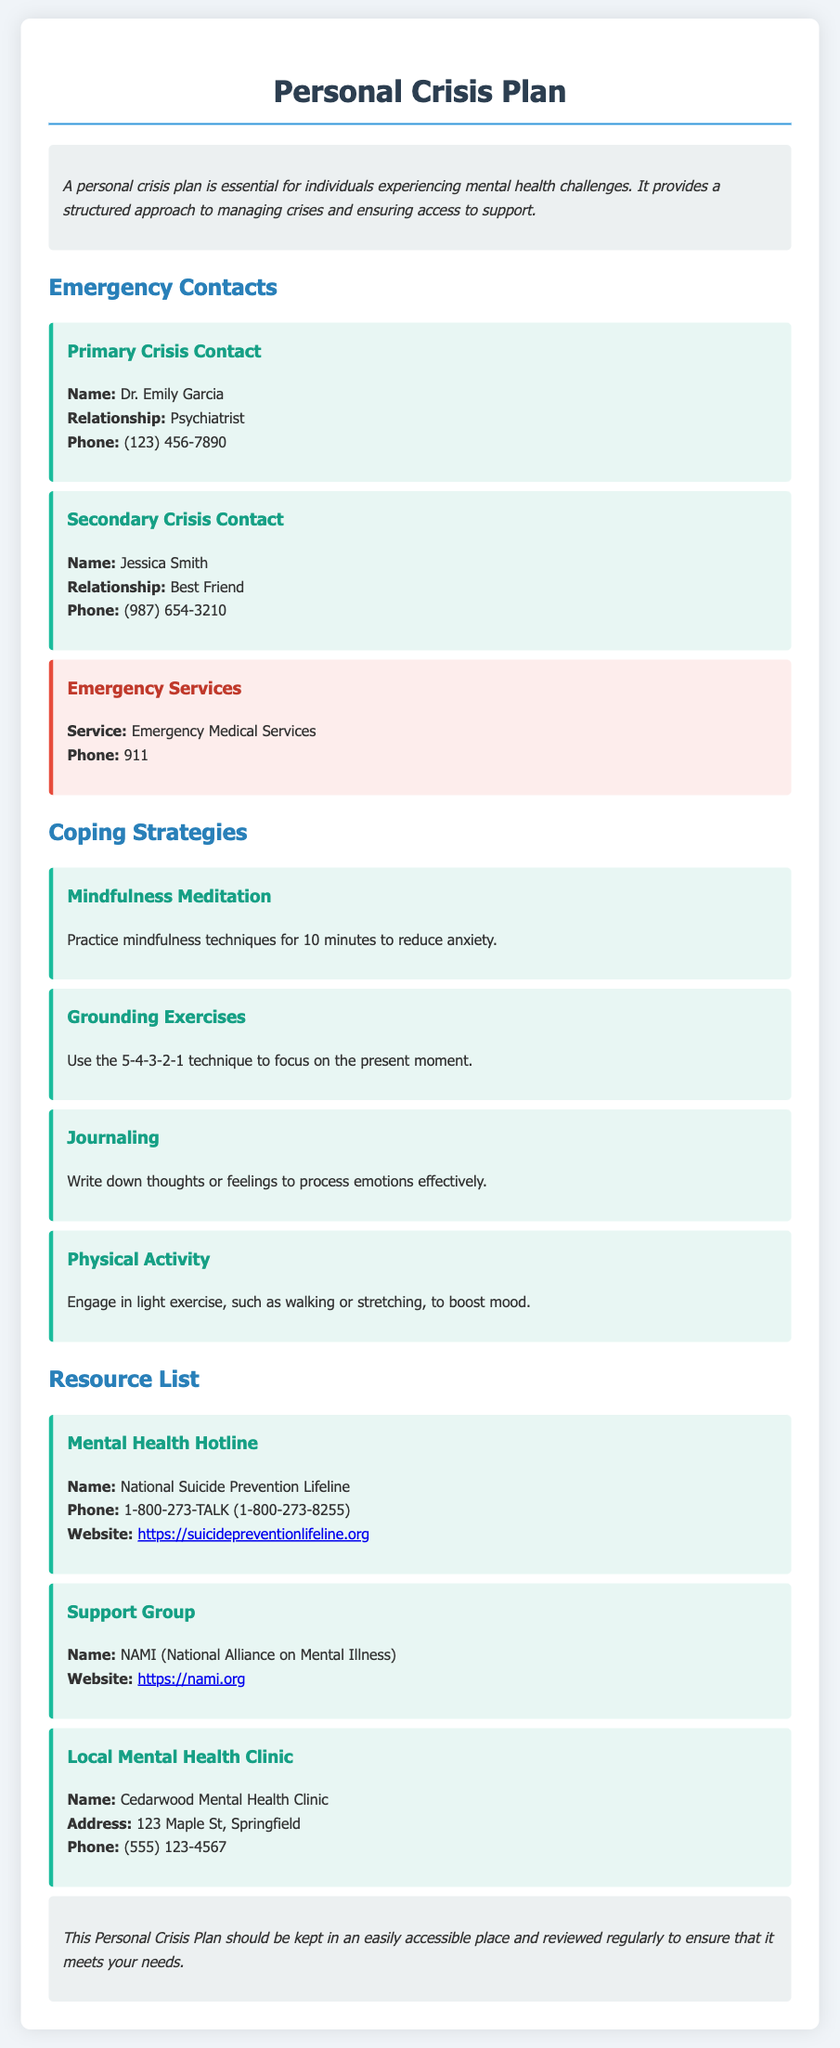What is the name of the primary crisis contact? The primary crisis contact listed in the document is Dr. Emily Garcia.
Answer: Dr. Emily Garcia What is the phone number for emergency services? The phone number for Emergency Medical Services, as stated in the document, is 911.
Answer: 911 What coping strategy involves writing down thoughts or feelings? The coping strategy that involves writing down thoughts or feelings is Journaling.
Answer: Journaling What is the website for the National Suicide Prevention Lifeline? The website provided in the document for the National Suicide Prevention Lifeline is https://suicidepreventionlifeline.org.
Answer: https://suicidepreventionlifeline.org How many coping strategies are listed in the document? The document lists four different coping strategies in total.
Answer: Four What is the relationship of Jessica Smith to the primary contact? Jessica Smith is listed as the Best Friend of the primary crisis contact in the document.
Answer: Best Friend What type of document is this? The document is a Personal Crisis Plan.
Answer: Personal Crisis Plan What technique is suggested for grounding exercises? The document recommends using the 5-4-3-2-1 technique for grounding exercises.
Answer: 5-4-3-2-1 technique 